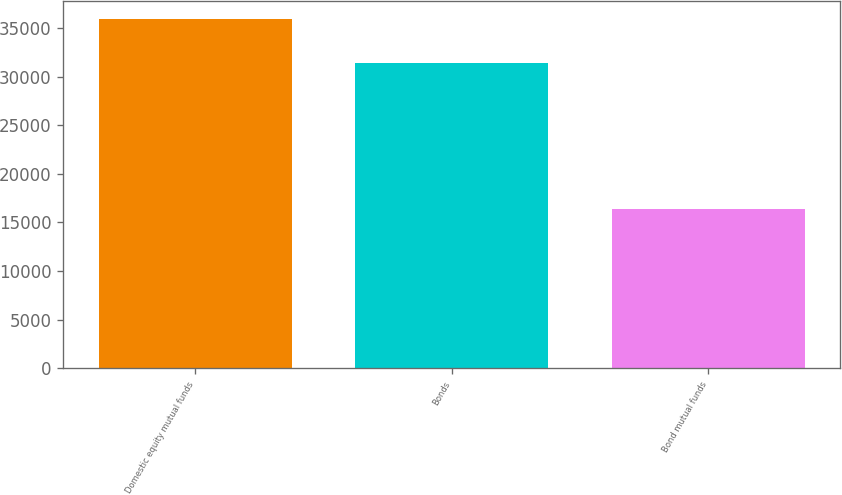<chart> <loc_0><loc_0><loc_500><loc_500><bar_chart><fcel>Domestic equity mutual funds<fcel>Bonds<fcel>Bond mutual funds<nl><fcel>35960<fcel>31400<fcel>16371<nl></chart> 